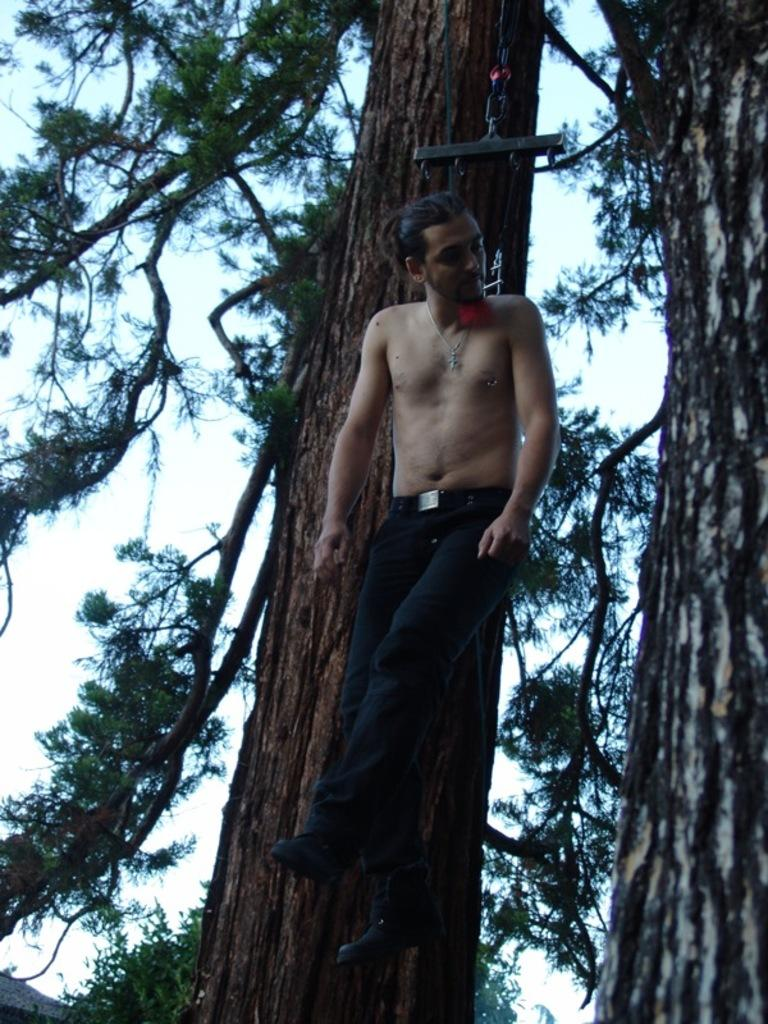What is the man in the image doing? The man is hanging on a rope in the image. What can be seen in the image besides the man? There are two trees in the image. What is visible in the background of the image? The sky is visible in the background of the image. What type of straw is the man using to write his name on the trees? There is no straw or writing present in the image; the man is simply hanging on a rope. 